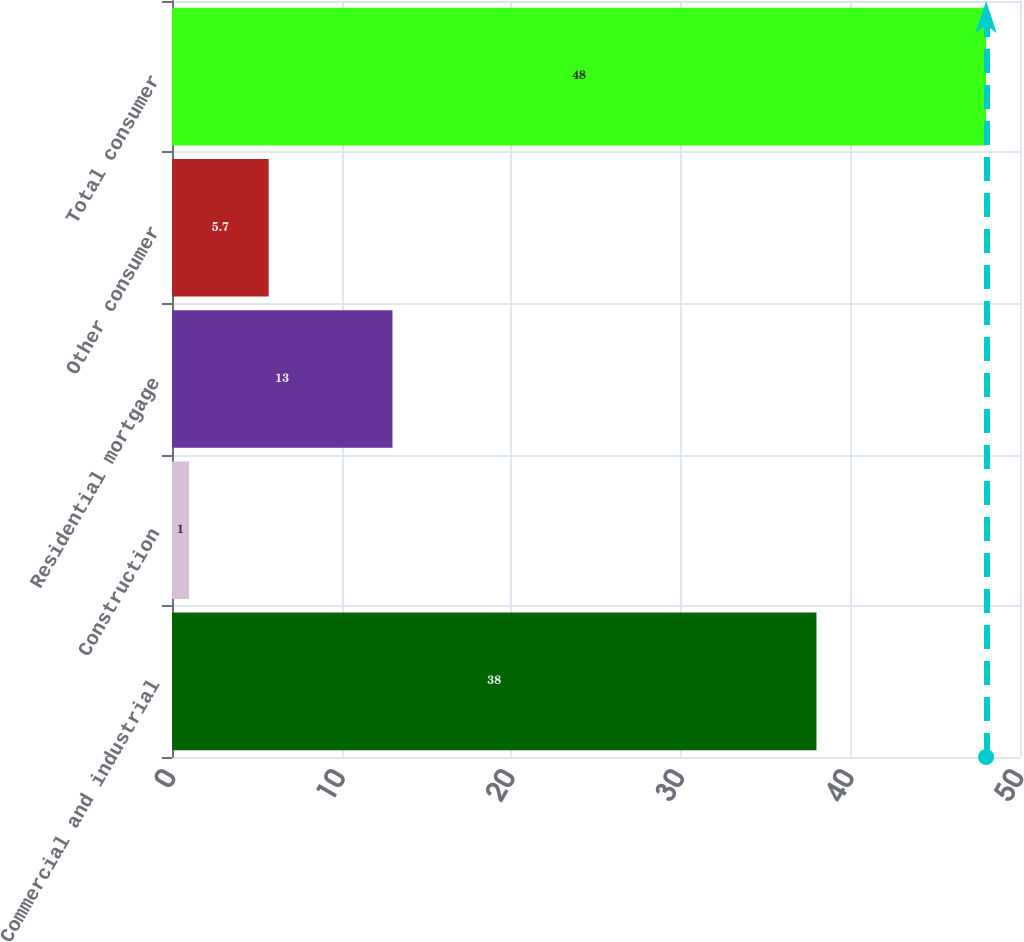Convert chart to OTSL. <chart><loc_0><loc_0><loc_500><loc_500><bar_chart><fcel>Commercial and industrial<fcel>Construction<fcel>Residential mortgage<fcel>Other consumer<fcel>Total consumer<nl><fcel>38<fcel>1<fcel>13<fcel>5.7<fcel>48<nl></chart> 